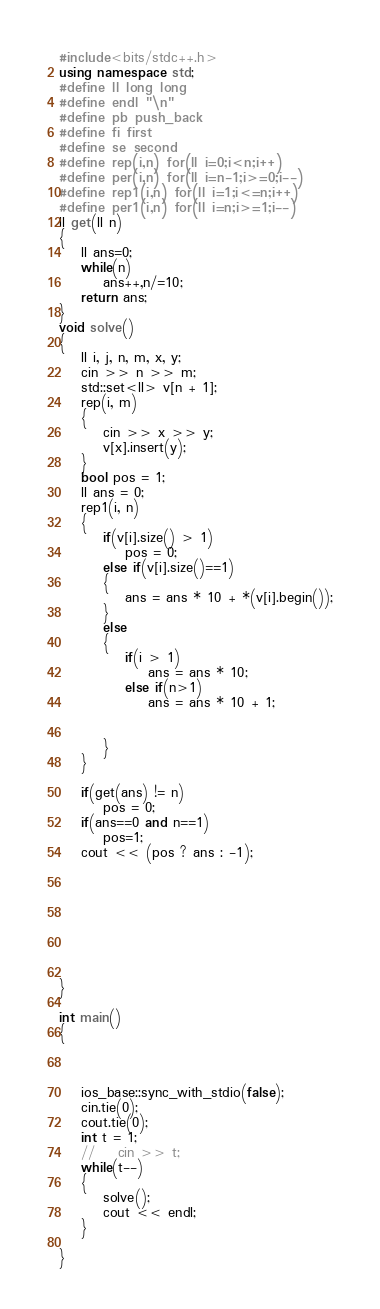Convert code to text. <code><loc_0><loc_0><loc_500><loc_500><_C++_>#include<bits/stdc++.h>
using namespace std;
#define ll long long
#define endl "\n"
#define pb push_back
#define fi first
#define se second
#define rep(i,n) for(ll i=0;i<n;i++)
#define per(i,n) for(ll i=n-1;i>=0;i--)
#define rep1(i,n) for(ll i=1;i<=n;i++)
#define per1(i,n) for(ll i=n;i>=1;i--)
ll get(ll n)
{
	ll ans=0;
	while(n)
		ans++,n/=10;
	return ans;
}
void solve()
{
    ll i, j, n, m, x, y;
    cin >> n >> m;
    std::set<ll> v[n + 1];
    rep(i, m)
    {
        cin >> x >> y;
        v[x].insert(y);
    }
    bool pos = 1;
    ll ans = 0;
    rep1(i, n)
    {
        if(v[i].size() > 1)
            pos = 0;
        else if(v[i].size()==1)
        {
            ans = ans * 10 + *(v[i].begin());
        }
        else
        {
            if(i > 1)
                ans = ans * 10;
            else if(n>1)
                ans = ans * 10 + 1;
           

        }
    }
  
    if(get(ans) != n)
        pos = 0;
    if(ans==0 and n==1)
    	pos=1;
    cout << (pos ? ans : -1);








}

int main()
{



    ios_base::sync_with_stdio(false);
    cin.tie(0);
    cout.tie(0);
    int t = 1;
    //    cin >> t;
    while(t--)
    {
        solve();
        cout << endl;
    }

}


</code> 